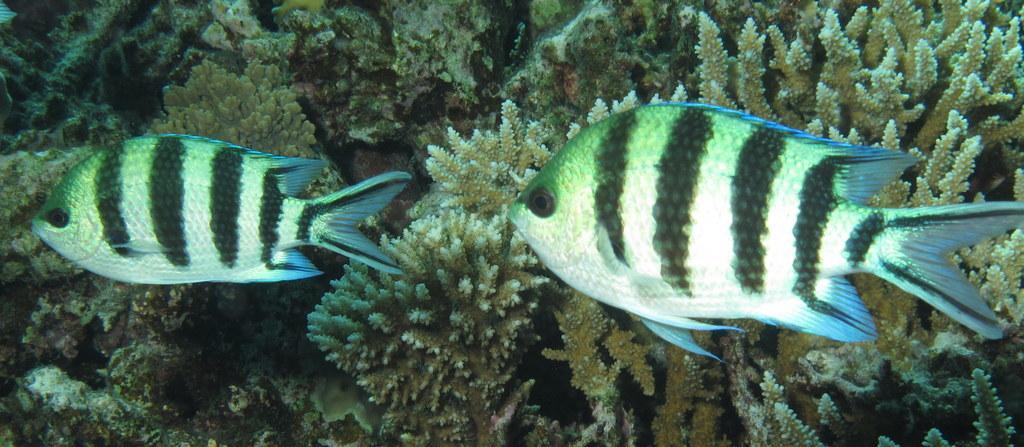In one or two sentences, can you explain what this image depicts? In this image, there are fishes beside water plants. 